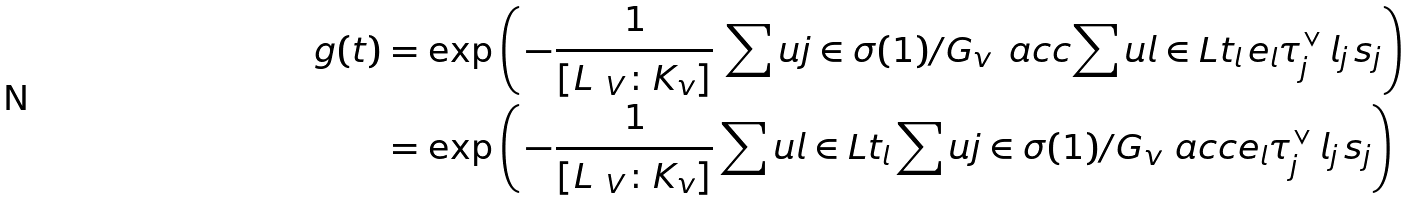Convert formula to latex. <formula><loc_0><loc_0><loc_500><loc_500>g ( t ) & = \exp \left ( \, - \frac { 1 } { [ L _ { \ V } \colon K _ { v } ] } \, \sum u { j \in \sigma ( 1 ) / G _ { v } } \, \ a c c { \sum u { l \in L } t _ { l } \, e _ { l } } { \tau _ { j } ^ { \vee } } \, l _ { j } \, s _ { j } \right ) \\ & = \exp \left ( \, - \frac { 1 } { [ L _ { \ V } \colon K _ { v } ] } \sum u { l \in L } t _ { l } \sum u { j \in \sigma ( 1 ) / G _ { v } } \ a c c { e _ { l } } { \tau _ { j } ^ { \vee } } \, l _ { j } \, s _ { j } \right )</formula> 